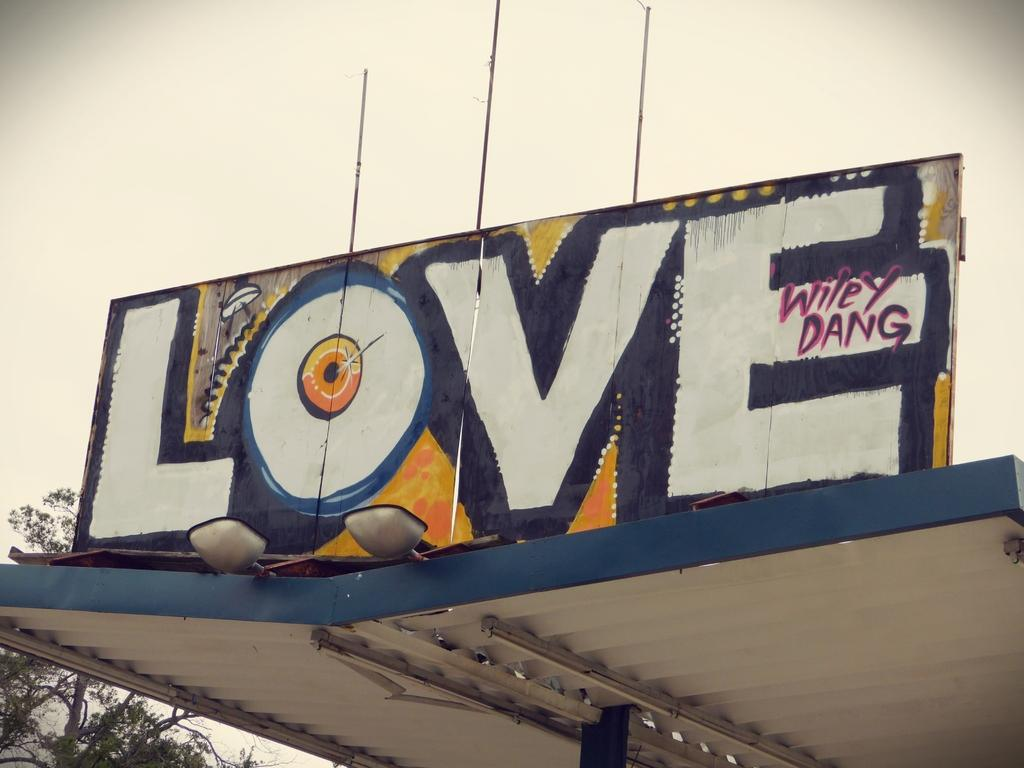<image>
Create a compact narrative representing the image presented. Grafitti on top of a surface that says "LOVE" by wiley Dang. 